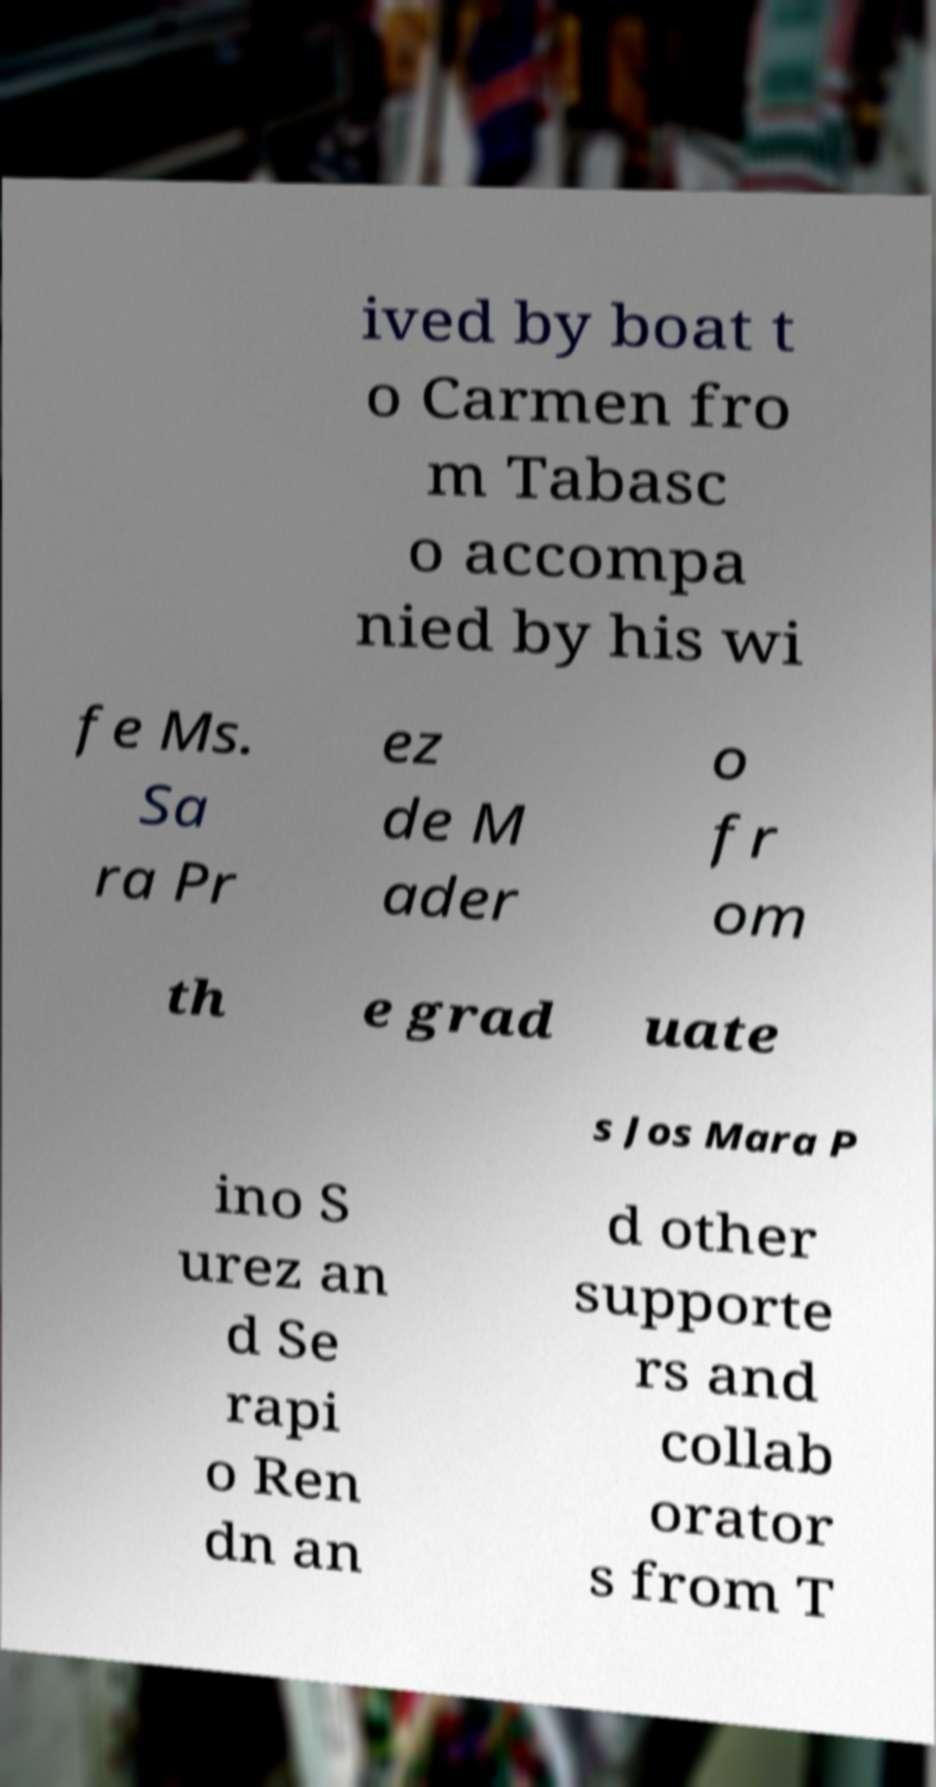Can you accurately transcribe the text from the provided image for me? ived by boat t o Carmen fro m Tabasc o accompa nied by his wi fe Ms. Sa ra Pr ez de M ader o fr om th e grad uate s Jos Mara P ino S urez an d Se rapi o Ren dn an d other supporte rs and collab orator s from T 